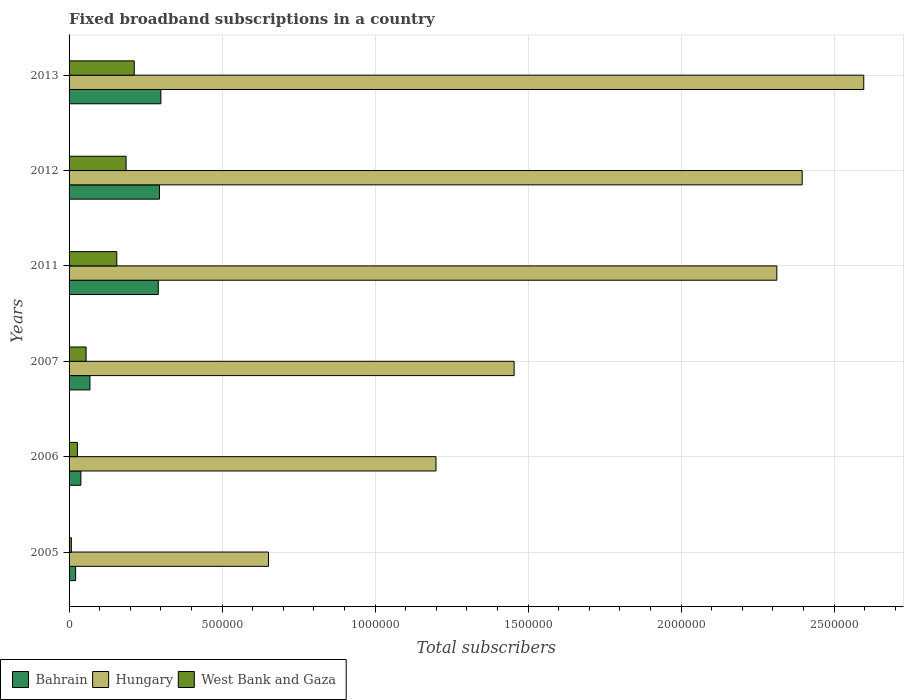How many groups of bars are there?
Your answer should be very brief. 6. Are the number of bars per tick equal to the number of legend labels?
Your answer should be very brief. Yes. How many bars are there on the 3rd tick from the top?
Provide a short and direct response. 3. What is the number of broadband subscriptions in Hungary in 2005?
Make the answer very short. 6.52e+05. Across all years, what is the maximum number of broadband subscriptions in West Bank and Gaza?
Make the answer very short. 2.13e+05. Across all years, what is the minimum number of broadband subscriptions in West Bank and Gaza?
Provide a short and direct response. 7463. In which year was the number of broadband subscriptions in Hungary minimum?
Make the answer very short. 2005. What is the total number of broadband subscriptions in Hungary in the graph?
Make the answer very short. 1.06e+07. What is the difference between the number of broadband subscriptions in Bahrain in 2005 and that in 2012?
Provide a succinct answer. -2.74e+05. What is the difference between the number of broadband subscriptions in West Bank and Gaza in 2007 and the number of broadband subscriptions in Hungary in 2012?
Ensure brevity in your answer.  -2.34e+06. What is the average number of broadband subscriptions in Hungary per year?
Ensure brevity in your answer.  1.77e+06. In the year 2005, what is the difference between the number of broadband subscriptions in West Bank and Gaza and number of broadband subscriptions in Hungary?
Your answer should be compact. -6.44e+05. In how many years, is the number of broadband subscriptions in Bahrain greater than 2200000 ?
Provide a short and direct response. 0. What is the ratio of the number of broadband subscriptions in West Bank and Gaza in 2006 to that in 2007?
Give a very brief answer. 0.49. Is the number of broadband subscriptions in Hungary in 2012 less than that in 2013?
Keep it short and to the point. Yes. What is the difference between the highest and the second highest number of broadband subscriptions in Bahrain?
Your response must be concise. 4669. What is the difference between the highest and the lowest number of broadband subscriptions in Hungary?
Provide a short and direct response. 1.95e+06. Is the sum of the number of broadband subscriptions in Bahrain in 2005 and 2006 greater than the maximum number of broadband subscriptions in West Bank and Gaza across all years?
Offer a very short reply. No. What does the 2nd bar from the top in 2007 represents?
Give a very brief answer. Hungary. What does the 1st bar from the bottom in 2007 represents?
Make the answer very short. Bahrain. Are all the bars in the graph horizontal?
Make the answer very short. Yes. Does the graph contain any zero values?
Ensure brevity in your answer.  No. What is the title of the graph?
Provide a short and direct response. Fixed broadband subscriptions in a country. What is the label or title of the X-axis?
Your response must be concise. Total subscribers. What is the label or title of the Y-axis?
Make the answer very short. Years. What is the Total subscribers of Bahrain in 2005?
Your response must be concise. 2.14e+04. What is the Total subscribers in Hungary in 2005?
Give a very brief answer. 6.52e+05. What is the Total subscribers in West Bank and Gaza in 2005?
Offer a terse response. 7463. What is the Total subscribers in Bahrain in 2006?
Provide a succinct answer. 3.86e+04. What is the Total subscribers of Hungary in 2006?
Ensure brevity in your answer.  1.20e+06. What is the Total subscribers in West Bank and Gaza in 2006?
Give a very brief answer. 2.72e+04. What is the Total subscribers of Bahrain in 2007?
Provide a succinct answer. 6.83e+04. What is the Total subscribers of Hungary in 2007?
Make the answer very short. 1.45e+06. What is the Total subscribers in West Bank and Gaza in 2007?
Your answer should be very brief. 5.56e+04. What is the Total subscribers of Bahrain in 2011?
Keep it short and to the point. 2.92e+05. What is the Total subscribers in Hungary in 2011?
Give a very brief answer. 2.31e+06. What is the Total subscribers in West Bank and Gaza in 2011?
Give a very brief answer. 1.56e+05. What is the Total subscribers of Bahrain in 2012?
Make the answer very short. 2.95e+05. What is the Total subscribers in Hungary in 2012?
Your answer should be compact. 2.40e+06. What is the Total subscribers in West Bank and Gaza in 2012?
Keep it short and to the point. 1.86e+05. What is the Total subscribers of Bahrain in 2013?
Give a very brief answer. 3.00e+05. What is the Total subscribers in Hungary in 2013?
Offer a very short reply. 2.60e+06. What is the Total subscribers in West Bank and Gaza in 2013?
Offer a very short reply. 2.13e+05. Across all years, what is the maximum Total subscribers of Bahrain?
Make the answer very short. 3.00e+05. Across all years, what is the maximum Total subscribers of Hungary?
Offer a terse response. 2.60e+06. Across all years, what is the maximum Total subscribers of West Bank and Gaza?
Your answer should be very brief. 2.13e+05. Across all years, what is the minimum Total subscribers in Bahrain?
Provide a short and direct response. 2.14e+04. Across all years, what is the minimum Total subscribers of Hungary?
Keep it short and to the point. 6.52e+05. Across all years, what is the minimum Total subscribers of West Bank and Gaza?
Your answer should be very brief. 7463. What is the total Total subscribers in Bahrain in the graph?
Provide a short and direct response. 1.02e+06. What is the total Total subscribers in Hungary in the graph?
Offer a very short reply. 1.06e+07. What is the total Total subscribers in West Bank and Gaza in the graph?
Your answer should be very brief. 6.46e+05. What is the difference between the Total subscribers in Bahrain in 2005 and that in 2006?
Your answer should be very brief. -1.72e+04. What is the difference between the Total subscribers in Hungary in 2005 and that in 2006?
Make the answer very short. -5.48e+05. What is the difference between the Total subscribers in West Bank and Gaza in 2005 and that in 2006?
Your answer should be compact. -1.97e+04. What is the difference between the Total subscribers in Bahrain in 2005 and that in 2007?
Your response must be concise. -4.68e+04. What is the difference between the Total subscribers of Hungary in 2005 and that in 2007?
Offer a very short reply. -8.03e+05. What is the difference between the Total subscribers in West Bank and Gaza in 2005 and that in 2007?
Offer a terse response. -4.82e+04. What is the difference between the Total subscribers of Bahrain in 2005 and that in 2011?
Give a very brief answer. -2.70e+05. What is the difference between the Total subscribers in Hungary in 2005 and that in 2011?
Make the answer very short. -1.66e+06. What is the difference between the Total subscribers in West Bank and Gaza in 2005 and that in 2011?
Ensure brevity in your answer.  -1.49e+05. What is the difference between the Total subscribers in Bahrain in 2005 and that in 2012?
Keep it short and to the point. -2.74e+05. What is the difference between the Total subscribers in Hungary in 2005 and that in 2012?
Your answer should be very brief. -1.74e+06. What is the difference between the Total subscribers of West Bank and Gaza in 2005 and that in 2012?
Keep it short and to the point. -1.79e+05. What is the difference between the Total subscribers in Bahrain in 2005 and that in 2013?
Your answer should be very brief. -2.79e+05. What is the difference between the Total subscribers in Hungary in 2005 and that in 2013?
Offer a terse response. -1.95e+06. What is the difference between the Total subscribers in West Bank and Gaza in 2005 and that in 2013?
Provide a succinct answer. -2.06e+05. What is the difference between the Total subscribers in Bahrain in 2006 and that in 2007?
Offer a terse response. -2.96e+04. What is the difference between the Total subscribers of Hungary in 2006 and that in 2007?
Keep it short and to the point. -2.55e+05. What is the difference between the Total subscribers in West Bank and Gaza in 2006 and that in 2007?
Make the answer very short. -2.85e+04. What is the difference between the Total subscribers in Bahrain in 2006 and that in 2011?
Offer a very short reply. -2.53e+05. What is the difference between the Total subscribers in Hungary in 2006 and that in 2011?
Make the answer very short. -1.11e+06. What is the difference between the Total subscribers in West Bank and Gaza in 2006 and that in 2011?
Keep it short and to the point. -1.29e+05. What is the difference between the Total subscribers in Bahrain in 2006 and that in 2012?
Your answer should be compact. -2.57e+05. What is the difference between the Total subscribers in Hungary in 2006 and that in 2012?
Your answer should be compact. -1.20e+06. What is the difference between the Total subscribers of West Bank and Gaza in 2006 and that in 2012?
Your response must be concise. -1.59e+05. What is the difference between the Total subscribers of Bahrain in 2006 and that in 2013?
Give a very brief answer. -2.61e+05. What is the difference between the Total subscribers in Hungary in 2006 and that in 2013?
Offer a very short reply. -1.40e+06. What is the difference between the Total subscribers in West Bank and Gaza in 2006 and that in 2013?
Your response must be concise. -1.86e+05. What is the difference between the Total subscribers of Bahrain in 2007 and that in 2011?
Your answer should be compact. -2.23e+05. What is the difference between the Total subscribers in Hungary in 2007 and that in 2011?
Ensure brevity in your answer.  -8.59e+05. What is the difference between the Total subscribers of West Bank and Gaza in 2007 and that in 2011?
Provide a succinct answer. -1.00e+05. What is the difference between the Total subscribers in Bahrain in 2007 and that in 2012?
Provide a succinct answer. -2.27e+05. What is the difference between the Total subscribers of Hungary in 2007 and that in 2012?
Offer a terse response. -9.42e+05. What is the difference between the Total subscribers of West Bank and Gaza in 2007 and that in 2012?
Ensure brevity in your answer.  -1.31e+05. What is the difference between the Total subscribers of Bahrain in 2007 and that in 2013?
Give a very brief answer. -2.32e+05. What is the difference between the Total subscribers in Hungary in 2007 and that in 2013?
Give a very brief answer. -1.14e+06. What is the difference between the Total subscribers of West Bank and Gaza in 2007 and that in 2013?
Your response must be concise. -1.57e+05. What is the difference between the Total subscribers of Bahrain in 2011 and that in 2012?
Offer a terse response. -3866. What is the difference between the Total subscribers of Hungary in 2011 and that in 2012?
Keep it short and to the point. -8.29e+04. What is the difference between the Total subscribers in West Bank and Gaza in 2011 and that in 2012?
Keep it short and to the point. -3.04e+04. What is the difference between the Total subscribers of Bahrain in 2011 and that in 2013?
Provide a succinct answer. -8535. What is the difference between the Total subscribers of Hungary in 2011 and that in 2013?
Give a very brief answer. -2.84e+05. What is the difference between the Total subscribers of West Bank and Gaza in 2011 and that in 2013?
Offer a terse response. -5.71e+04. What is the difference between the Total subscribers in Bahrain in 2012 and that in 2013?
Offer a very short reply. -4669. What is the difference between the Total subscribers in Hungary in 2012 and that in 2013?
Provide a short and direct response. -2.01e+05. What is the difference between the Total subscribers in West Bank and Gaza in 2012 and that in 2013?
Give a very brief answer. -2.67e+04. What is the difference between the Total subscribers of Bahrain in 2005 and the Total subscribers of Hungary in 2006?
Your response must be concise. -1.18e+06. What is the difference between the Total subscribers of Bahrain in 2005 and the Total subscribers of West Bank and Gaza in 2006?
Keep it short and to the point. -5740. What is the difference between the Total subscribers in Hungary in 2005 and the Total subscribers in West Bank and Gaza in 2006?
Your answer should be compact. 6.25e+05. What is the difference between the Total subscribers in Bahrain in 2005 and the Total subscribers in Hungary in 2007?
Your answer should be very brief. -1.43e+06. What is the difference between the Total subscribers in Bahrain in 2005 and the Total subscribers in West Bank and Gaza in 2007?
Provide a short and direct response. -3.42e+04. What is the difference between the Total subscribers in Hungary in 2005 and the Total subscribers in West Bank and Gaza in 2007?
Offer a terse response. 5.96e+05. What is the difference between the Total subscribers in Bahrain in 2005 and the Total subscribers in Hungary in 2011?
Offer a terse response. -2.29e+06. What is the difference between the Total subscribers in Bahrain in 2005 and the Total subscribers in West Bank and Gaza in 2011?
Ensure brevity in your answer.  -1.35e+05. What is the difference between the Total subscribers in Hungary in 2005 and the Total subscribers in West Bank and Gaza in 2011?
Keep it short and to the point. 4.96e+05. What is the difference between the Total subscribers of Bahrain in 2005 and the Total subscribers of Hungary in 2012?
Give a very brief answer. -2.37e+06. What is the difference between the Total subscribers in Bahrain in 2005 and the Total subscribers in West Bank and Gaza in 2012?
Offer a terse response. -1.65e+05. What is the difference between the Total subscribers in Hungary in 2005 and the Total subscribers in West Bank and Gaza in 2012?
Your response must be concise. 4.65e+05. What is the difference between the Total subscribers in Bahrain in 2005 and the Total subscribers in Hungary in 2013?
Your response must be concise. -2.58e+06. What is the difference between the Total subscribers of Bahrain in 2005 and the Total subscribers of West Bank and Gaza in 2013?
Ensure brevity in your answer.  -1.92e+05. What is the difference between the Total subscribers of Hungary in 2005 and the Total subscribers of West Bank and Gaza in 2013?
Ensure brevity in your answer.  4.39e+05. What is the difference between the Total subscribers of Bahrain in 2006 and the Total subscribers of Hungary in 2007?
Provide a succinct answer. -1.42e+06. What is the difference between the Total subscribers of Bahrain in 2006 and the Total subscribers of West Bank and Gaza in 2007?
Give a very brief answer. -1.70e+04. What is the difference between the Total subscribers of Hungary in 2006 and the Total subscribers of West Bank and Gaza in 2007?
Provide a succinct answer. 1.14e+06. What is the difference between the Total subscribers of Bahrain in 2006 and the Total subscribers of Hungary in 2011?
Give a very brief answer. -2.27e+06. What is the difference between the Total subscribers of Bahrain in 2006 and the Total subscribers of West Bank and Gaza in 2011?
Give a very brief answer. -1.17e+05. What is the difference between the Total subscribers in Hungary in 2006 and the Total subscribers in West Bank and Gaza in 2011?
Make the answer very short. 1.04e+06. What is the difference between the Total subscribers in Bahrain in 2006 and the Total subscribers in Hungary in 2012?
Your answer should be compact. -2.36e+06. What is the difference between the Total subscribers in Bahrain in 2006 and the Total subscribers in West Bank and Gaza in 2012?
Ensure brevity in your answer.  -1.48e+05. What is the difference between the Total subscribers of Hungary in 2006 and the Total subscribers of West Bank and Gaza in 2012?
Make the answer very short. 1.01e+06. What is the difference between the Total subscribers of Bahrain in 2006 and the Total subscribers of Hungary in 2013?
Make the answer very short. -2.56e+06. What is the difference between the Total subscribers of Bahrain in 2006 and the Total subscribers of West Bank and Gaza in 2013?
Your response must be concise. -1.74e+05. What is the difference between the Total subscribers in Hungary in 2006 and the Total subscribers in West Bank and Gaza in 2013?
Provide a short and direct response. 9.86e+05. What is the difference between the Total subscribers in Bahrain in 2007 and the Total subscribers in Hungary in 2011?
Provide a succinct answer. -2.24e+06. What is the difference between the Total subscribers of Bahrain in 2007 and the Total subscribers of West Bank and Gaza in 2011?
Keep it short and to the point. -8.77e+04. What is the difference between the Total subscribers of Hungary in 2007 and the Total subscribers of West Bank and Gaza in 2011?
Your answer should be very brief. 1.30e+06. What is the difference between the Total subscribers of Bahrain in 2007 and the Total subscribers of Hungary in 2012?
Your answer should be compact. -2.33e+06. What is the difference between the Total subscribers of Bahrain in 2007 and the Total subscribers of West Bank and Gaza in 2012?
Your answer should be compact. -1.18e+05. What is the difference between the Total subscribers of Hungary in 2007 and the Total subscribers of West Bank and Gaza in 2012?
Provide a short and direct response. 1.27e+06. What is the difference between the Total subscribers in Bahrain in 2007 and the Total subscribers in Hungary in 2013?
Offer a very short reply. -2.53e+06. What is the difference between the Total subscribers in Bahrain in 2007 and the Total subscribers in West Bank and Gaza in 2013?
Offer a terse response. -1.45e+05. What is the difference between the Total subscribers in Hungary in 2007 and the Total subscribers in West Bank and Gaza in 2013?
Make the answer very short. 1.24e+06. What is the difference between the Total subscribers of Bahrain in 2011 and the Total subscribers of Hungary in 2012?
Your response must be concise. -2.10e+06. What is the difference between the Total subscribers in Bahrain in 2011 and the Total subscribers in West Bank and Gaza in 2012?
Keep it short and to the point. 1.05e+05. What is the difference between the Total subscribers in Hungary in 2011 and the Total subscribers in West Bank and Gaza in 2012?
Ensure brevity in your answer.  2.13e+06. What is the difference between the Total subscribers in Bahrain in 2011 and the Total subscribers in Hungary in 2013?
Ensure brevity in your answer.  -2.31e+06. What is the difference between the Total subscribers of Bahrain in 2011 and the Total subscribers of West Bank and Gaza in 2013?
Your response must be concise. 7.85e+04. What is the difference between the Total subscribers in Hungary in 2011 and the Total subscribers in West Bank and Gaza in 2013?
Your answer should be compact. 2.10e+06. What is the difference between the Total subscribers in Bahrain in 2012 and the Total subscribers in Hungary in 2013?
Provide a succinct answer. -2.30e+06. What is the difference between the Total subscribers in Bahrain in 2012 and the Total subscribers in West Bank and Gaza in 2013?
Offer a terse response. 8.23e+04. What is the difference between the Total subscribers of Hungary in 2012 and the Total subscribers of West Bank and Gaza in 2013?
Offer a very short reply. 2.18e+06. What is the average Total subscribers in Bahrain per year?
Make the answer very short. 1.69e+05. What is the average Total subscribers in Hungary per year?
Give a very brief answer. 1.77e+06. What is the average Total subscribers in West Bank and Gaza per year?
Your answer should be compact. 1.08e+05. In the year 2005, what is the difference between the Total subscribers in Bahrain and Total subscribers in Hungary?
Provide a succinct answer. -6.30e+05. In the year 2005, what is the difference between the Total subscribers of Bahrain and Total subscribers of West Bank and Gaza?
Provide a short and direct response. 1.40e+04. In the year 2005, what is the difference between the Total subscribers in Hungary and Total subscribers in West Bank and Gaza?
Give a very brief answer. 6.44e+05. In the year 2006, what is the difference between the Total subscribers of Bahrain and Total subscribers of Hungary?
Offer a very short reply. -1.16e+06. In the year 2006, what is the difference between the Total subscribers of Bahrain and Total subscribers of West Bank and Gaza?
Your answer should be compact. 1.15e+04. In the year 2006, what is the difference between the Total subscribers of Hungary and Total subscribers of West Bank and Gaza?
Make the answer very short. 1.17e+06. In the year 2007, what is the difference between the Total subscribers of Bahrain and Total subscribers of Hungary?
Your response must be concise. -1.39e+06. In the year 2007, what is the difference between the Total subscribers in Bahrain and Total subscribers in West Bank and Gaza?
Give a very brief answer. 1.26e+04. In the year 2007, what is the difference between the Total subscribers of Hungary and Total subscribers of West Bank and Gaza?
Keep it short and to the point. 1.40e+06. In the year 2011, what is the difference between the Total subscribers of Bahrain and Total subscribers of Hungary?
Provide a short and direct response. -2.02e+06. In the year 2011, what is the difference between the Total subscribers of Bahrain and Total subscribers of West Bank and Gaza?
Ensure brevity in your answer.  1.36e+05. In the year 2011, what is the difference between the Total subscribers of Hungary and Total subscribers of West Bank and Gaza?
Offer a very short reply. 2.16e+06. In the year 2012, what is the difference between the Total subscribers of Bahrain and Total subscribers of Hungary?
Your answer should be very brief. -2.10e+06. In the year 2012, what is the difference between the Total subscribers in Bahrain and Total subscribers in West Bank and Gaza?
Give a very brief answer. 1.09e+05. In the year 2012, what is the difference between the Total subscribers of Hungary and Total subscribers of West Bank and Gaza?
Keep it short and to the point. 2.21e+06. In the year 2013, what is the difference between the Total subscribers of Bahrain and Total subscribers of Hungary?
Provide a succinct answer. -2.30e+06. In the year 2013, what is the difference between the Total subscribers of Bahrain and Total subscribers of West Bank and Gaza?
Keep it short and to the point. 8.70e+04. In the year 2013, what is the difference between the Total subscribers of Hungary and Total subscribers of West Bank and Gaza?
Give a very brief answer. 2.38e+06. What is the ratio of the Total subscribers in Bahrain in 2005 to that in 2006?
Keep it short and to the point. 0.55. What is the ratio of the Total subscribers of Hungary in 2005 to that in 2006?
Your response must be concise. 0.54. What is the ratio of the Total subscribers in West Bank and Gaza in 2005 to that in 2006?
Your response must be concise. 0.27. What is the ratio of the Total subscribers of Bahrain in 2005 to that in 2007?
Provide a short and direct response. 0.31. What is the ratio of the Total subscribers in Hungary in 2005 to that in 2007?
Offer a terse response. 0.45. What is the ratio of the Total subscribers in West Bank and Gaza in 2005 to that in 2007?
Offer a very short reply. 0.13. What is the ratio of the Total subscribers in Bahrain in 2005 to that in 2011?
Your answer should be very brief. 0.07. What is the ratio of the Total subscribers of Hungary in 2005 to that in 2011?
Your answer should be compact. 0.28. What is the ratio of the Total subscribers in West Bank and Gaza in 2005 to that in 2011?
Offer a very short reply. 0.05. What is the ratio of the Total subscribers of Bahrain in 2005 to that in 2012?
Give a very brief answer. 0.07. What is the ratio of the Total subscribers of Hungary in 2005 to that in 2012?
Make the answer very short. 0.27. What is the ratio of the Total subscribers of West Bank and Gaza in 2005 to that in 2012?
Offer a very short reply. 0.04. What is the ratio of the Total subscribers of Bahrain in 2005 to that in 2013?
Your answer should be very brief. 0.07. What is the ratio of the Total subscribers in Hungary in 2005 to that in 2013?
Offer a terse response. 0.25. What is the ratio of the Total subscribers in West Bank and Gaza in 2005 to that in 2013?
Give a very brief answer. 0.04. What is the ratio of the Total subscribers of Bahrain in 2006 to that in 2007?
Ensure brevity in your answer.  0.57. What is the ratio of the Total subscribers in Hungary in 2006 to that in 2007?
Give a very brief answer. 0.82. What is the ratio of the Total subscribers of West Bank and Gaza in 2006 to that in 2007?
Offer a terse response. 0.49. What is the ratio of the Total subscribers of Bahrain in 2006 to that in 2011?
Your answer should be very brief. 0.13. What is the ratio of the Total subscribers of Hungary in 2006 to that in 2011?
Provide a short and direct response. 0.52. What is the ratio of the Total subscribers in West Bank and Gaza in 2006 to that in 2011?
Offer a very short reply. 0.17. What is the ratio of the Total subscribers in Bahrain in 2006 to that in 2012?
Your answer should be very brief. 0.13. What is the ratio of the Total subscribers of Hungary in 2006 to that in 2012?
Offer a terse response. 0.5. What is the ratio of the Total subscribers in West Bank and Gaza in 2006 to that in 2012?
Keep it short and to the point. 0.15. What is the ratio of the Total subscribers in Bahrain in 2006 to that in 2013?
Your response must be concise. 0.13. What is the ratio of the Total subscribers in Hungary in 2006 to that in 2013?
Offer a terse response. 0.46. What is the ratio of the Total subscribers in West Bank and Gaza in 2006 to that in 2013?
Your response must be concise. 0.13. What is the ratio of the Total subscribers in Bahrain in 2007 to that in 2011?
Provide a succinct answer. 0.23. What is the ratio of the Total subscribers in Hungary in 2007 to that in 2011?
Make the answer very short. 0.63. What is the ratio of the Total subscribers of West Bank and Gaza in 2007 to that in 2011?
Keep it short and to the point. 0.36. What is the ratio of the Total subscribers of Bahrain in 2007 to that in 2012?
Make the answer very short. 0.23. What is the ratio of the Total subscribers in Hungary in 2007 to that in 2012?
Your response must be concise. 0.61. What is the ratio of the Total subscribers of West Bank and Gaza in 2007 to that in 2012?
Give a very brief answer. 0.3. What is the ratio of the Total subscribers of Bahrain in 2007 to that in 2013?
Offer a terse response. 0.23. What is the ratio of the Total subscribers in Hungary in 2007 to that in 2013?
Your answer should be compact. 0.56. What is the ratio of the Total subscribers in West Bank and Gaza in 2007 to that in 2013?
Provide a succinct answer. 0.26. What is the ratio of the Total subscribers in Bahrain in 2011 to that in 2012?
Offer a very short reply. 0.99. What is the ratio of the Total subscribers of Hungary in 2011 to that in 2012?
Provide a short and direct response. 0.97. What is the ratio of the Total subscribers in West Bank and Gaza in 2011 to that in 2012?
Your answer should be very brief. 0.84. What is the ratio of the Total subscribers of Bahrain in 2011 to that in 2013?
Ensure brevity in your answer.  0.97. What is the ratio of the Total subscribers of Hungary in 2011 to that in 2013?
Provide a succinct answer. 0.89. What is the ratio of the Total subscribers in West Bank and Gaza in 2011 to that in 2013?
Your response must be concise. 0.73. What is the ratio of the Total subscribers of Bahrain in 2012 to that in 2013?
Make the answer very short. 0.98. What is the ratio of the Total subscribers of Hungary in 2012 to that in 2013?
Your answer should be very brief. 0.92. What is the ratio of the Total subscribers of West Bank and Gaza in 2012 to that in 2013?
Provide a succinct answer. 0.87. What is the difference between the highest and the second highest Total subscribers in Bahrain?
Your response must be concise. 4669. What is the difference between the highest and the second highest Total subscribers in Hungary?
Keep it short and to the point. 2.01e+05. What is the difference between the highest and the second highest Total subscribers of West Bank and Gaza?
Provide a succinct answer. 2.67e+04. What is the difference between the highest and the lowest Total subscribers in Bahrain?
Make the answer very short. 2.79e+05. What is the difference between the highest and the lowest Total subscribers of Hungary?
Keep it short and to the point. 1.95e+06. What is the difference between the highest and the lowest Total subscribers in West Bank and Gaza?
Ensure brevity in your answer.  2.06e+05. 